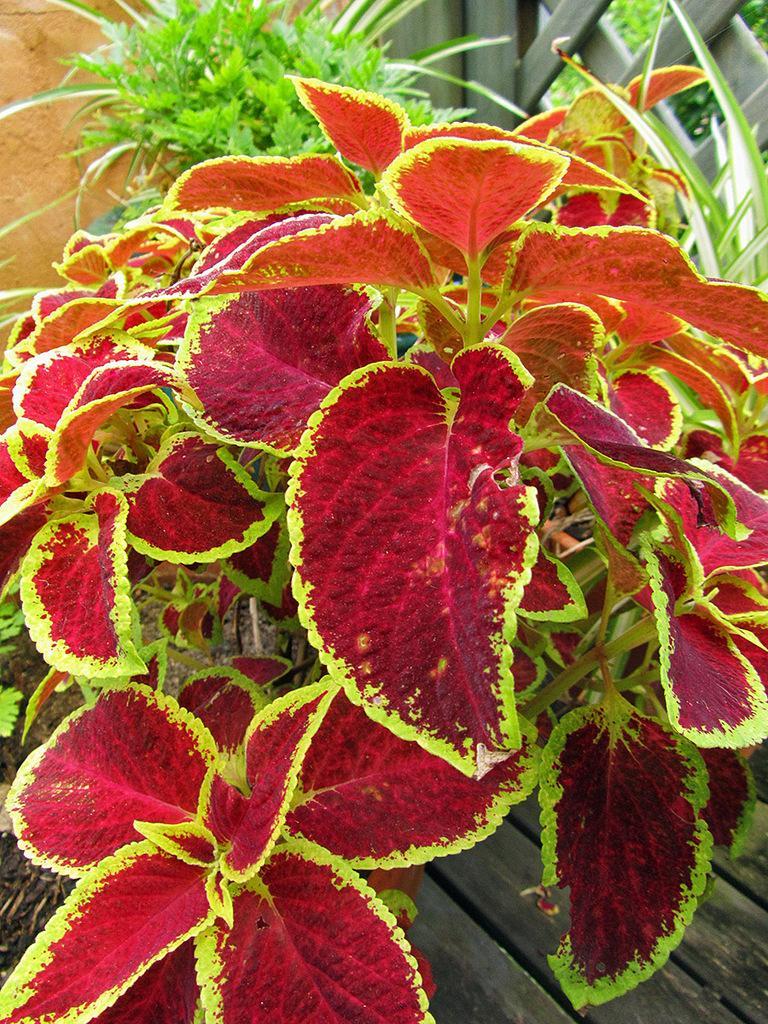In one or two sentences, can you explain what this image depicts? In the picture we can see some plants on the wooden plank, and the leaves of the plant are red in color with green color borders to it and behind it we can see other plants. 